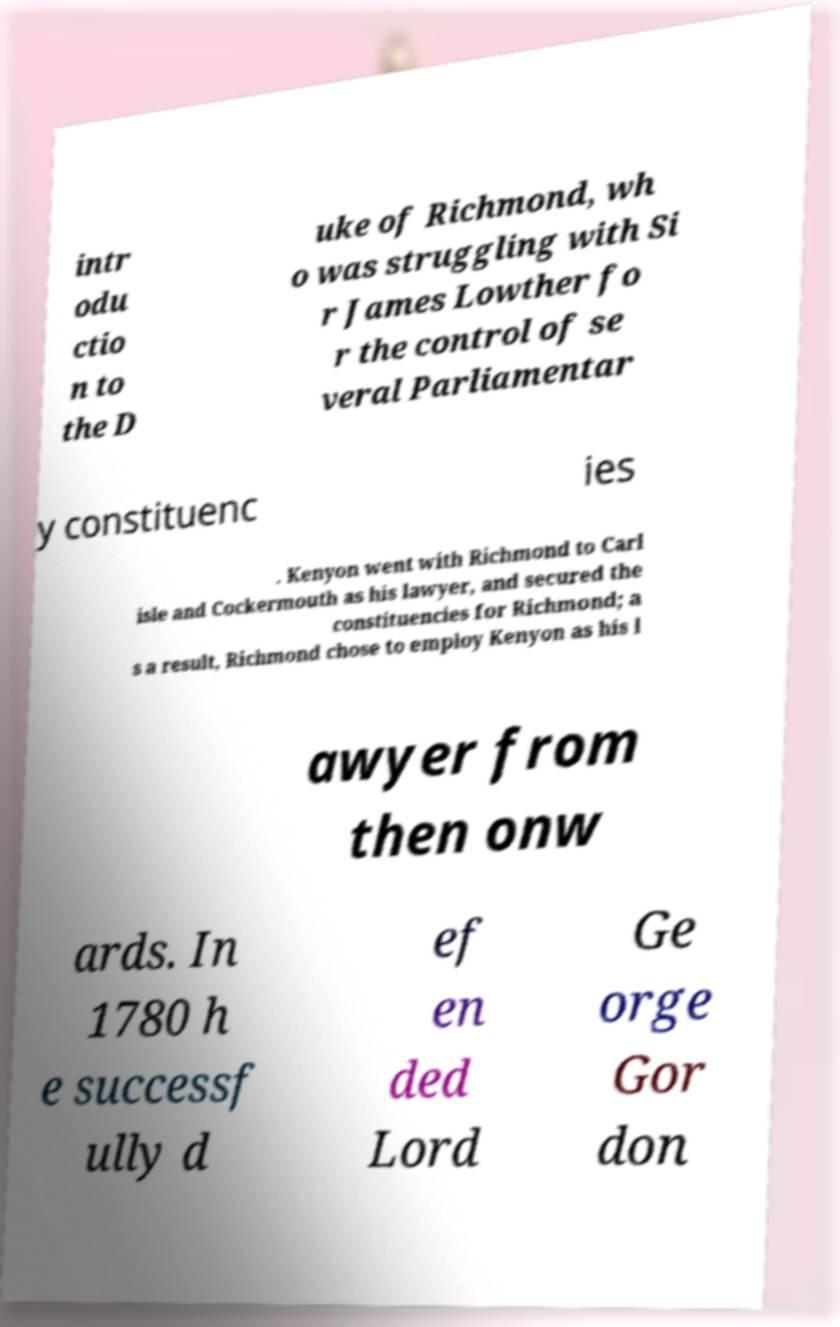Can you read and provide the text displayed in the image?This photo seems to have some interesting text. Can you extract and type it out for me? intr odu ctio n to the D uke of Richmond, wh o was struggling with Si r James Lowther fo r the control of se veral Parliamentar y constituenc ies . Kenyon went with Richmond to Carl isle and Cockermouth as his lawyer, and secured the constituencies for Richmond; a s a result, Richmond chose to employ Kenyon as his l awyer from then onw ards. In 1780 h e successf ully d ef en ded Lord Ge orge Gor don 